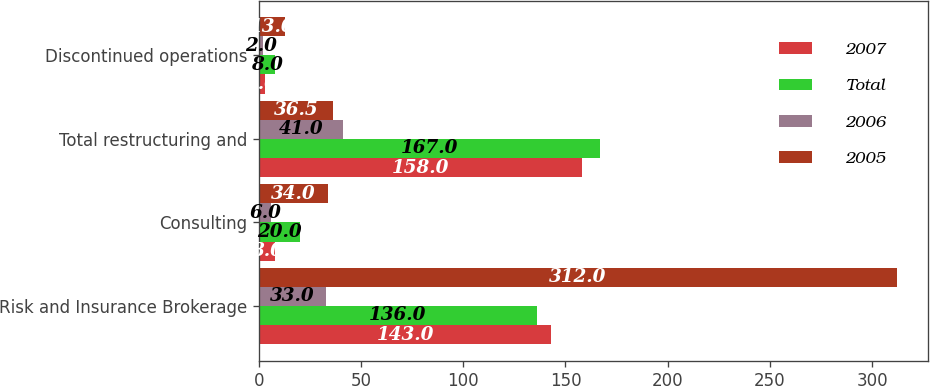Convert chart to OTSL. <chart><loc_0><loc_0><loc_500><loc_500><stacked_bar_chart><ecel><fcel>Risk and Insurance Brokerage<fcel>Consulting<fcel>Total restructuring and<fcel>Discontinued operations<nl><fcel>2007<fcel>143<fcel>8<fcel>158<fcel>3<nl><fcel>Total<fcel>136<fcel>20<fcel>167<fcel>8<nl><fcel>2006<fcel>33<fcel>6<fcel>41<fcel>2<nl><fcel>2005<fcel>312<fcel>34<fcel>36.5<fcel>13<nl></chart> 